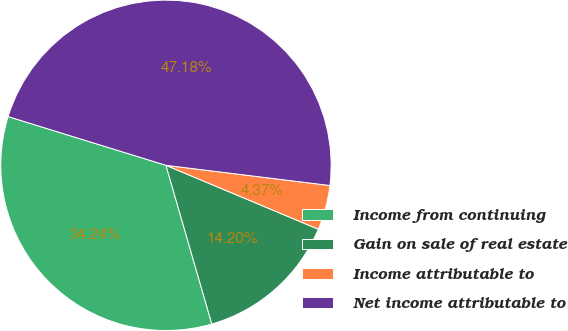<chart> <loc_0><loc_0><loc_500><loc_500><pie_chart><fcel>Income from continuing<fcel>Gain on sale of real estate<fcel>Income attributable to<fcel>Net income attributable to<nl><fcel>34.24%<fcel>14.2%<fcel>4.37%<fcel>47.18%<nl></chart> 